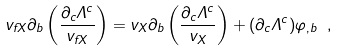<formula> <loc_0><loc_0><loc_500><loc_500>v _ { f X } \partial _ { b } \left ( \frac { \partial _ { c } \Lambda ^ { c } } { v _ { f X } } \right ) = v _ { X } \partial _ { b } \left ( \frac { \partial _ { c } \Lambda ^ { c } } { v _ { X } } \right ) + ( \partial _ { c } \Lambda ^ { c } ) \varphi _ { , b } \ ,</formula> 